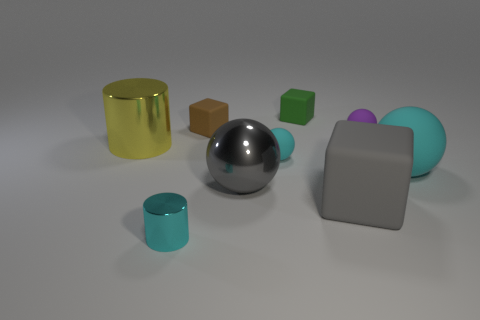The small metallic cylinder has what color?
Ensure brevity in your answer.  Cyan. There is a metal object that is in front of the yellow cylinder and behind the tiny cyan metallic object; what is its size?
Your answer should be very brief. Large. How many objects are either small rubber objects behind the brown rubber block or big gray things?
Ensure brevity in your answer.  3. The large yellow object that is made of the same material as the big gray ball is what shape?
Ensure brevity in your answer.  Cylinder. What is the shape of the big gray rubber thing?
Keep it short and to the point. Cube. There is a matte thing that is both behind the yellow metal cylinder and in front of the brown object; what color is it?
Offer a very short reply. Purple. What shape is the yellow object that is the same size as the gray matte cube?
Make the answer very short. Cylinder. Are there any tiny purple rubber objects that have the same shape as the small cyan metallic object?
Offer a terse response. No. Does the yellow thing have the same material as the cyan ball on the left side of the big gray cube?
Your answer should be very brief. No. The cube that is to the right of the tiny matte block to the right of the matte sphere on the left side of the large rubber block is what color?
Offer a very short reply. Gray. 